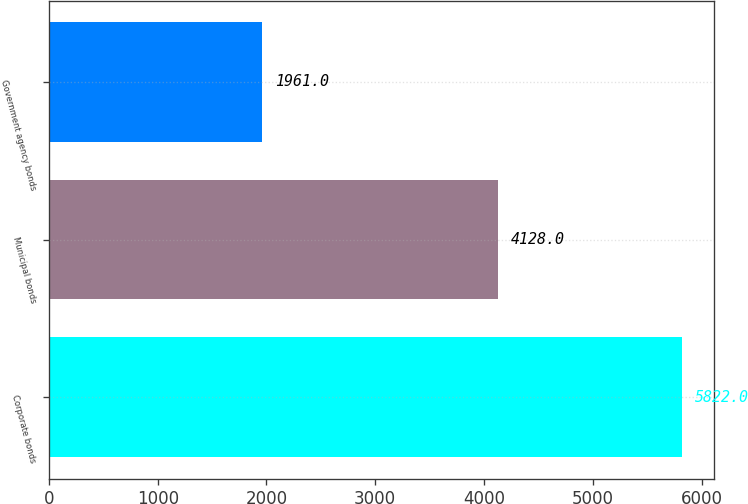Convert chart to OTSL. <chart><loc_0><loc_0><loc_500><loc_500><bar_chart><fcel>Corporate bonds<fcel>Municipal bonds<fcel>Government agency bonds<nl><fcel>5822<fcel>4128<fcel>1961<nl></chart> 